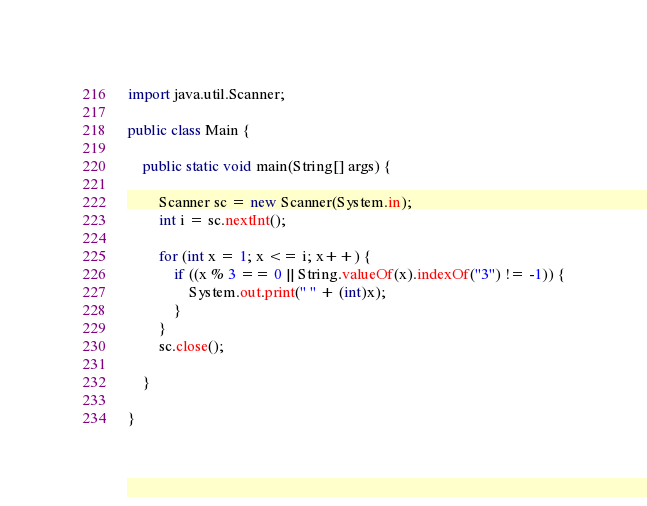Convert code to text. <code><loc_0><loc_0><loc_500><loc_500><_Java_>import java.util.Scanner;

public class Main {

	public static void main(String[] args) {

		Scanner sc = new Scanner(System.in);
		int i = sc.nextInt();

		for (int x = 1; x <= i; x++) {
			if ((x % 3 == 0 || String.valueOf(x).indexOf("3") != -1)) {
				System.out.print(" " + (int)x);
			}
		}
		sc.close();

	}

}</code> 